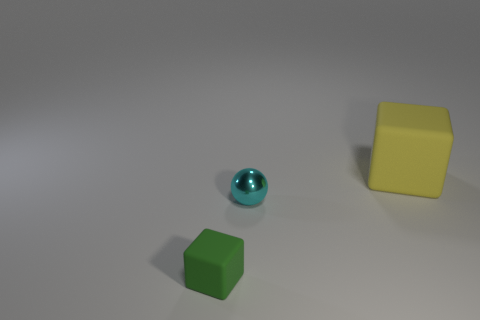Subtract all cubes. How many objects are left? 1 Add 3 yellow objects. How many yellow objects are left? 4 Add 1 brown matte objects. How many brown matte objects exist? 1 Add 1 yellow things. How many objects exist? 4 Subtract all yellow blocks. How many blocks are left? 1 Subtract 0 green spheres. How many objects are left? 3 Subtract all brown balls. Subtract all yellow cubes. How many balls are left? 1 Subtract all yellow cylinders. How many yellow cubes are left? 1 Subtract all metallic spheres. Subtract all tiny cyan balls. How many objects are left? 1 